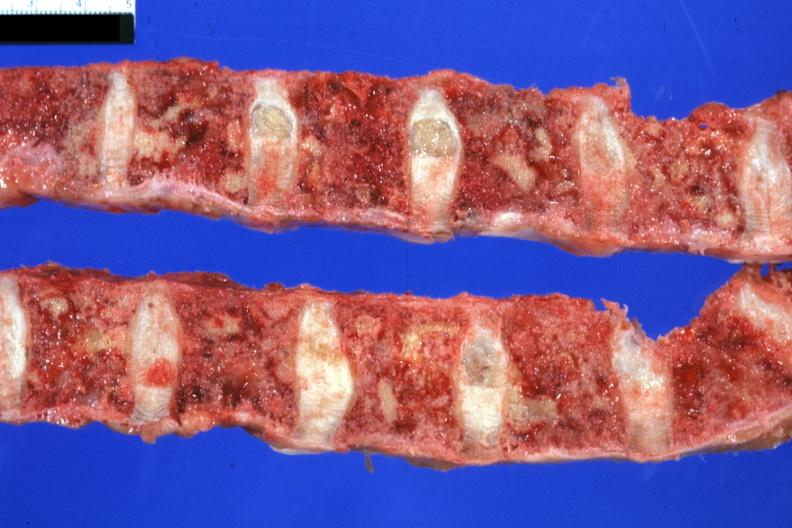s joints present?
Answer the question using a single word or phrase. Yes 